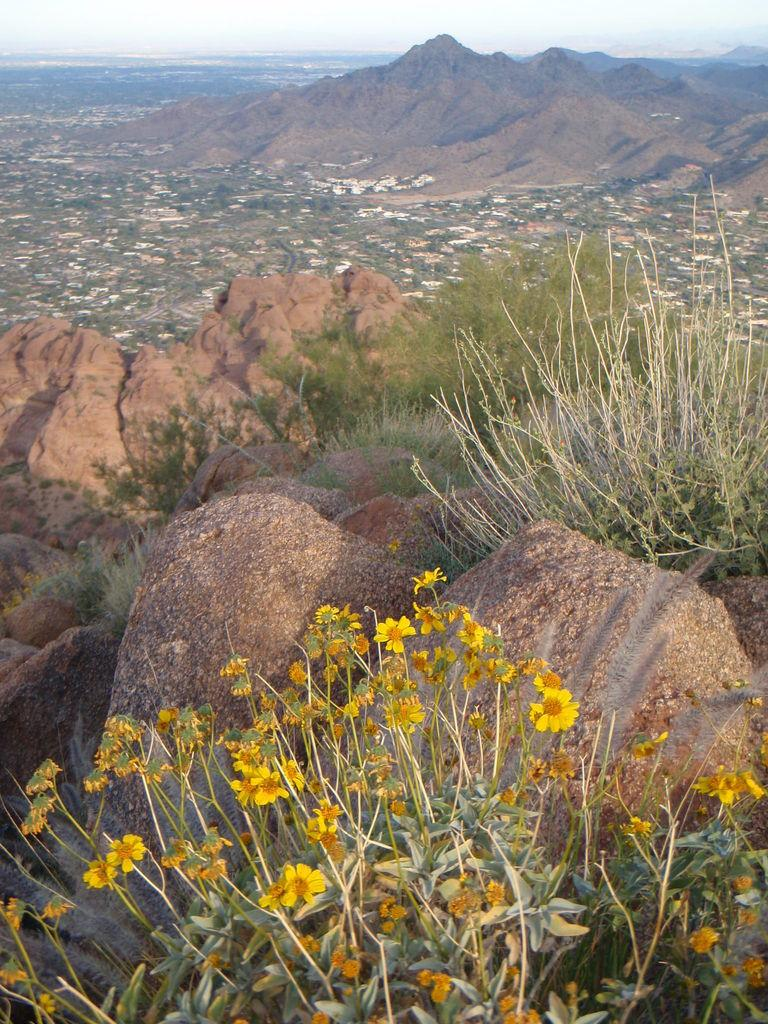What type of plant is present in the image? There is a plant with yellow flowers in the image. What other natural elements can be seen in the image? There are trees and rocks in the image. What geographical feature is depicted in the image? The image appears to depict a hill. What can be seen in the distance in the image? The view of the city, including buildings and trees, is visible in the image. How many units of the sack are visible in the image? There is no sack present in the image. What type of deer can be seen grazing on the hill in the image? There are no deer present in the image; it only features a plant, trees, rocks, and a city view. 